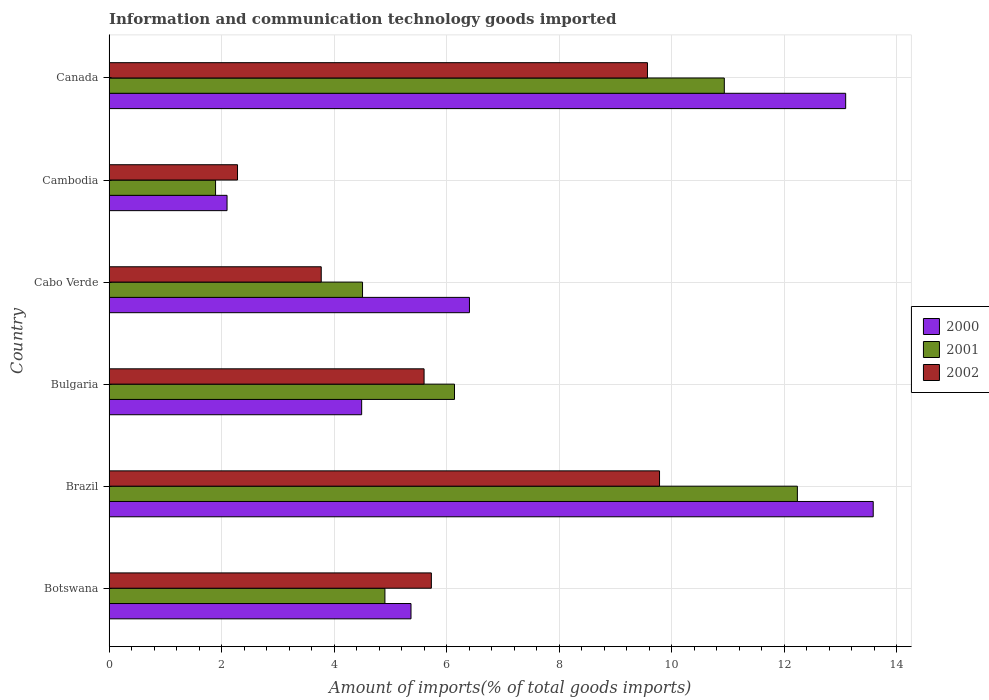How many different coloured bars are there?
Provide a succinct answer. 3. What is the label of the 1st group of bars from the top?
Provide a short and direct response. Canada. In how many cases, is the number of bars for a given country not equal to the number of legend labels?
Offer a very short reply. 0. What is the amount of goods imported in 2002 in Brazil?
Provide a succinct answer. 9.78. Across all countries, what is the maximum amount of goods imported in 2000?
Offer a terse response. 13.58. Across all countries, what is the minimum amount of goods imported in 2000?
Your response must be concise. 2.1. In which country was the amount of goods imported in 2002 maximum?
Your response must be concise. Brazil. In which country was the amount of goods imported in 2001 minimum?
Your answer should be very brief. Cambodia. What is the total amount of goods imported in 2001 in the graph?
Your answer should be very brief. 40.6. What is the difference between the amount of goods imported in 2002 in Brazil and that in Cambodia?
Keep it short and to the point. 7.5. What is the difference between the amount of goods imported in 2002 in Canada and the amount of goods imported in 2001 in Cambodia?
Offer a terse response. 7.67. What is the average amount of goods imported in 2001 per country?
Give a very brief answer. 6.77. What is the difference between the amount of goods imported in 2002 and amount of goods imported in 2001 in Canada?
Ensure brevity in your answer.  -1.37. What is the ratio of the amount of goods imported in 2000 in Brazil to that in Canada?
Keep it short and to the point. 1.04. What is the difference between the highest and the second highest amount of goods imported in 2001?
Make the answer very short. 1.3. What is the difference between the highest and the lowest amount of goods imported in 2002?
Provide a succinct answer. 7.5. In how many countries, is the amount of goods imported in 2001 greater than the average amount of goods imported in 2001 taken over all countries?
Your response must be concise. 2. Is the sum of the amount of goods imported in 2000 in Bulgaria and Canada greater than the maximum amount of goods imported in 2001 across all countries?
Offer a terse response. Yes. What does the 2nd bar from the top in Botswana represents?
Provide a succinct answer. 2001. What is the difference between two consecutive major ticks on the X-axis?
Give a very brief answer. 2. Does the graph contain grids?
Your answer should be very brief. Yes. What is the title of the graph?
Offer a very short reply. Information and communication technology goods imported. What is the label or title of the X-axis?
Provide a short and direct response. Amount of imports(% of total goods imports). What is the label or title of the Y-axis?
Give a very brief answer. Country. What is the Amount of imports(% of total goods imports) of 2000 in Botswana?
Provide a short and direct response. 5.37. What is the Amount of imports(% of total goods imports) of 2001 in Botswana?
Ensure brevity in your answer.  4.9. What is the Amount of imports(% of total goods imports) of 2002 in Botswana?
Your answer should be compact. 5.73. What is the Amount of imports(% of total goods imports) in 2000 in Brazil?
Offer a very short reply. 13.58. What is the Amount of imports(% of total goods imports) of 2001 in Brazil?
Give a very brief answer. 12.23. What is the Amount of imports(% of total goods imports) of 2002 in Brazil?
Keep it short and to the point. 9.78. What is the Amount of imports(% of total goods imports) in 2000 in Bulgaria?
Provide a short and direct response. 4.49. What is the Amount of imports(% of total goods imports) of 2001 in Bulgaria?
Give a very brief answer. 6.14. What is the Amount of imports(% of total goods imports) of 2002 in Bulgaria?
Offer a terse response. 5.6. What is the Amount of imports(% of total goods imports) of 2000 in Cabo Verde?
Your answer should be compact. 6.4. What is the Amount of imports(% of total goods imports) in 2001 in Cabo Verde?
Provide a succinct answer. 4.5. What is the Amount of imports(% of total goods imports) of 2002 in Cabo Verde?
Your answer should be compact. 3.77. What is the Amount of imports(% of total goods imports) of 2000 in Cambodia?
Keep it short and to the point. 2.1. What is the Amount of imports(% of total goods imports) in 2001 in Cambodia?
Provide a succinct answer. 1.89. What is the Amount of imports(% of total goods imports) in 2002 in Cambodia?
Provide a short and direct response. 2.28. What is the Amount of imports(% of total goods imports) in 2000 in Canada?
Provide a short and direct response. 13.09. What is the Amount of imports(% of total goods imports) of 2001 in Canada?
Provide a succinct answer. 10.93. What is the Amount of imports(% of total goods imports) of 2002 in Canada?
Your response must be concise. 9.57. Across all countries, what is the maximum Amount of imports(% of total goods imports) of 2000?
Keep it short and to the point. 13.58. Across all countries, what is the maximum Amount of imports(% of total goods imports) in 2001?
Keep it short and to the point. 12.23. Across all countries, what is the maximum Amount of imports(% of total goods imports) of 2002?
Your response must be concise. 9.78. Across all countries, what is the minimum Amount of imports(% of total goods imports) of 2000?
Ensure brevity in your answer.  2.1. Across all countries, what is the minimum Amount of imports(% of total goods imports) of 2001?
Your answer should be compact. 1.89. Across all countries, what is the minimum Amount of imports(% of total goods imports) in 2002?
Your answer should be compact. 2.28. What is the total Amount of imports(% of total goods imports) in 2000 in the graph?
Offer a very short reply. 45.02. What is the total Amount of imports(% of total goods imports) of 2001 in the graph?
Give a very brief answer. 40.6. What is the total Amount of imports(% of total goods imports) of 2002 in the graph?
Keep it short and to the point. 36.72. What is the difference between the Amount of imports(% of total goods imports) of 2000 in Botswana and that in Brazil?
Ensure brevity in your answer.  -8.21. What is the difference between the Amount of imports(% of total goods imports) of 2001 in Botswana and that in Brazil?
Ensure brevity in your answer.  -7.33. What is the difference between the Amount of imports(% of total goods imports) in 2002 in Botswana and that in Brazil?
Your answer should be very brief. -4.05. What is the difference between the Amount of imports(% of total goods imports) of 2000 in Botswana and that in Bulgaria?
Give a very brief answer. 0.88. What is the difference between the Amount of imports(% of total goods imports) of 2001 in Botswana and that in Bulgaria?
Ensure brevity in your answer.  -1.24. What is the difference between the Amount of imports(% of total goods imports) in 2002 in Botswana and that in Bulgaria?
Your answer should be compact. 0.13. What is the difference between the Amount of imports(% of total goods imports) in 2000 in Botswana and that in Cabo Verde?
Your answer should be compact. -1.04. What is the difference between the Amount of imports(% of total goods imports) in 2001 in Botswana and that in Cabo Verde?
Give a very brief answer. 0.4. What is the difference between the Amount of imports(% of total goods imports) of 2002 in Botswana and that in Cabo Verde?
Your answer should be very brief. 1.96. What is the difference between the Amount of imports(% of total goods imports) of 2000 in Botswana and that in Cambodia?
Offer a very short reply. 3.27. What is the difference between the Amount of imports(% of total goods imports) in 2001 in Botswana and that in Cambodia?
Offer a terse response. 3.01. What is the difference between the Amount of imports(% of total goods imports) of 2002 in Botswana and that in Cambodia?
Offer a terse response. 3.44. What is the difference between the Amount of imports(% of total goods imports) in 2000 in Botswana and that in Canada?
Provide a short and direct response. -7.72. What is the difference between the Amount of imports(% of total goods imports) of 2001 in Botswana and that in Canada?
Keep it short and to the point. -6.03. What is the difference between the Amount of imports(% of total goods imports) in 2002 in Botswana and that in Canada?
Provide a short and direct response. -3.84. What is the difference between the Amount of imports(% of total goods imports) of 2000 in Brazil and that in Bulgaria?
Ensure brevity in your answer.  9.09. What is the difference between the Amount of imports(% of total goods imports) of 2001 in Brazil and that in Bulgaria?
Your answer should be very brief. 6.09. What is the difference between the Amount of imports(% of total goods imports) of 2002 in Brazil and that in Bulgaria?
Ensure brevity in your answer.  4.18. What is the difference between the Amount of imports(% of total goods imports) of 2000 in Brazil and that in Cabo Verde?
Your response must be concise. 7.17. What is the difference between the Amount of imports(% of total goods imports) of 2001 in Brazil and that in Cabo Verde?
Your answer should be compact. 7.73. What is the difference between the Amount of imports(% of total goods imports) in 2002 in Brazil and that in Cabo Verde?
Your response must be concise. 6.01. What is the difference between the Amount of imports(% of total goods imports) of 2000 in Brazil and that in Cambodia?
Provide a short and direct response. 11.48. What is the difference between the Amount of imports(% of total goods imports) in 2001 in Brazil and that in Cambodia?
Offer a very short reply. 10.34. What is the difference between the Amount of imports(% of total goods imports) of 2002 in Brazil and that in Cambodia?
Ensure brevity in your answer.  7.5. What is the difference between the Amount of imports(% of total goods imports) in 2000 in Brazil and that in Canada?
Make the answer very short. 0.49. What is the difference between the Amount of imports(% of total goods imports) in 2001 in Brazil and that in Canada?
Keep it short and to the point. 1.3. What is the difference between the Amount of imports(% of total goods imports) in 2002 in Brazil and that in Canada?
Your answer should be very brief. 0.21. What is the difference between the Amount of imports(% of total goods imports) of 2000 in Bulgaria and that in Cabo Verde?
Give a very brief answer. -1.92. What is the difference between the Amount of imports(% of total goods imports) in 2001 in Bulgaria and that in Cabo Verde?
Provide a short and direct response. 1.63. What is the difference between the Amount of imports(% of total goods imports) of 2002 in Bulgaria and that in Cabo Verde?
Provide a succinct answer. 1.83. What is the difference between the Amount of imports(% of total goods imports) in 2000 in Bulgaria and that in Cambodia?
Offer a very short reply. 2.39. What is the difference between the Amount of imports(% of total goods imports) in 2001 in Bulgaria and that in Cambodia?
Ensure brevity in your answer.  4.25. What is the difference between the Amount of imports(% of total goods imports) in 2002 in Bulgaria and that in Cambodia?
Your answer should be compact. 3.31. What is the difference between the Amount of imports(% of total goods imports) of 2000 in Bulgaria and that in Canada?
Offer a terse response. -8.6. What is the difference between the Amount of imports(% of total goods imports) of 2001 in Bulgaria and that in Canada?
Your answer should be very brief. -4.79. What is the difference between the Amount of imports(% of total goods imports) in 2002 in Bulgaria and that in Canada?
Give a very brief answer. -3.97. What is the difference between the Amount of imports(% of total goods imports) in 2000 in Cabo Verde and that in Cambodia?
Offer a terse response. 4.31. What is the difference between the Amount of imports(% of total goods imports) of 2001 in Cabo Verde and that in Cambodia?
Keep it short and to the point. 2.61. What is the difference between the Amount of imports(% of total goods imports) of 2002 in Cabo Verde and that in Cambodia?
Provide a short and direct response. 1.49. What is the difference between the Amount of imports(% of total goods imports) in 2000 in Cabo Verde and that in Canada?
Your answer should be compact. -6.68. What is the difference between the Amount of imports(% of total goods imports) of 2001 in Cabo Verde and that in Canada?
Give a very brief answer. -6.43. What is the difference between the Amount of imports(% of total goods imports) of 2002 in Cabo Verde and that in Canada?
Give a very brief answer. -5.8. What is the difference between the Amount of imports(% of total goods imports) in 2000 in Cambodia and that in Canada?
Offer a very short reply. -10.99. What is the difference between the Amount of imports(% of total goods imports) of 2001 in Cambodia and that in Canada?
Your answer should be compact. -9.04. What is the difference between the Amount of imports(% of total goods imports) of 2002 in Cambodia and that in Canada?
Your response must be concise. -7.28. What is the difference between the Amount of imports(% of total goods imports) of 2000 in Botswana and the Amount of imports(% of total goods imports) of 2001 in Brazil?
Provide a succinct answer. -6.87. What is the difference between the Amount of imports(% of total goods imports) in 2000 in Botswana and the Amount of imports(% of total goods imports) in 2002 in Brazil?
Your response must be concise. -4.42. What is the difference between the Amount of imports(% of total goods imports) in 2001 in Botswana and the Amount of imports(% of total goods imports) in 2002 in Brazil?
Ensure brevity in your answer.  -4.88. What is the difference between the Amount of imports(% of total goods imports) in 2000 in Botswana and the Amount of imports(% of total goods imports) in 2001 in Bulgaria?
Your answer should be very brief. -0.77. What is the difference between the Amount of imports(% of total goods imports) of 2000 in Botswana and the Amount of imports(% of total goods imports) of 2002 in Bulgaria?
Your response must be concise. -0.23. What is the difference between the Amount of imports(% of total goods imports) of 2001 in Botswana and the Amount of imports(% of total goods imports) of 2002 in Bulgaria?
Make the answer very short. -0.7. What is the difference between the Amount of imports(% of total goods imports) of 2000 in Botswana and the Amount of imports(% of total goods imports) of 2001 in Cabo Verde?
Make the answer very short. 0.86. What is the difference between the Amount of imports(% of total goods imports) of 2000 in Botswana and the Amount of imports(% of total goods imports) of 2002 in Cabo Verde?
Provide a succinct answer. 1.6. What is the difference between the Amount of imports(% of total goods imports) of 2001 in Botswana and the Amount of imports(% of total goods imports) of 2002 in Cabo Verde?
Keep it short and to the point. 1.13. What is the difference between the Amount of imports(% of total goods imports) in 2000 in Botswana and the Amount of imports(% of total goods imports) in 2001 in Cambodia?
Your response must be concise. 3.47. What is the difference between the Amount of imports(% of total goods imports) in 2000 in Botswana and the Amount of imports(% of total goods imports) in 2002 in Cambodia?
Keep it short and to the point. 3.08. What is the difference between the Amount of imports(% of total goods imports) of 2001 in Botswana and the Amount of imports(% of total goods imports) of 2002 in Cambodia?
Give a very brief answer. 2.62. What is the difference between the Amount of imports(% of total goods imports) of 2000 in Botswana and the Amount of imports(% of total goods imports) of 2001 in Canada?
Ensure brevity in your answer.  -5.57. What is the difference between the Amount of imports(% of total goods imports) of 2000 in Botswana and the Amount of imports(% of total goods imports) of 2002 in Canada?
Your answer should be very brief. -4.2. What is the difference between the Amount of imports(% of total goods imports) in 2001 in Botswana and the Amount of imports(% of total goods imports) in 2002 in Canada?
Make the answer very short. -4.67. What is the difference between the Amount of imports(% of total goods imports) in 2000 in Brazil and the Amount of imports(% of total goods imports) in 2001 in Bulgaria?
Your answer should be compact. 7.44. What is the difference between the Amount of imports(% of total goods imports) in 2000 in Brazil and the Amount of imports(% of total goods imports) in 2002 in Bulgaria?
Offer a very short reply. 7.98. What is the difference between the Amount of imports(% of total goods imports) in 2001 in Brazil and the Amount of imports(% of total goods imports) in 2002 in Bulgaria?
Provide a succinct answer. 6.63. What is the difference between the Amount of imports(% of total goods imports) in 2000 in Brazil and the Amount of imports(% of total goods imports) in 2001 in Cabo Verde?
Your response must be concise. 9.07. What is the difference between the Amount of imports(% of total goods imports) in 2000 in Brazil and the Amount of imports(% of total goods imports) in 2002 in Cabo Verde?
Give a very brief answer. 9.81. What is the difference between the Amount of imports(% of total goods imports) in 2001 in Brazil and the Amount of imports(% of total goods imports) in 2002 in Cabo Verde?
Your response must be concise. 8.46. What is the difference between the Amount of imports(% of total goods imports) of 2000 in Brazil and the Amount of imports(% of total goods imports) of 2001 in Cambodia?
Offer a terse response. 11.69. What is the difference between the Amount of imports(% of total goods imports) in 2000 in Brazil and the Amount of imports(% of total goods imports) in 2002 in Cambodia?
Your answer should be very brief. 11.3. What is the difference between the Amount of imports(% of total goods imports) of 2001 in Brazil and the Amount of imports(% of total goods imports) of 2002 in Cambodia?
Give a very brief answer. 9.95. What is the difference between the Amount of imports(% of total goods imports) of 2000 in Brazil and the Amount of imports(% of total goods imports) of 2001 in Canada?
Make the answer very short. 2.65. What is the difference between the Amount of imports(% of total goods imports) in 2000 in Brazil and the Amount of imports(% of total goods imports) in 2002 in Canada?
Ensure brevity in your answer.  4.01. What is the difference between the Amount of imports(% of total goods imports) in 2001 in Brazil and the Amount of imports(% of total goods imports) in 2002 in Canada?
Keep it short and to the point. 2.66. What is the difference between the Amount of imports(% of total goods imports) of 2000 in Bulgaria and the Amount of imports(% of total goods imports) of 2001 in Cabo Verde?
Provide a succinct answer. -0.02. What is the difference between the Amount of imports(% of total goods imports) of 2000 in Bulgaria and the Amount of imports(% of total goods imports) of 2002 in Cabo Verde?
Offer a very short reply. 0.72. What is the difference between the Amount of imports(% of total goods imports) in 2001 in Bulgaria and the Amount of imports(% of total goods imports) in 2002 in Cabo Verde?
Your response must be concise. 2.37. What is the difference between the Amount of imports(% of total goods imports) in 2000 in Bulgaria and the Amount of imports(% of total goods imports) in 2001 in Cambodia?
Make the answer very short. 2.6. What is the difference between the Amount of imports(% of total goods imports) of 2000 in Bulgaria and the Amount of imports(% of total goods imports) of 2002 in Cambodia?
Make the answer very short. 2.21. What is the difference between the Amount of imports(% of total goods imports) in 2001 in Bulgaria and the Amount of imports(% of total goods imports) in 2002 in Cambodia?
Give a very brief answer. 3.86. What is the difference between the Amount of imports(% of total goods imports) in 2000 in Bulgaria and the Amount of imports(% of total goods imports) in 2001 in Canada?
Provide a short and direct response. -6.44. What is the difference between the Amount of imports(% of total goods imports) in 2000 in Bulgaria and the Amount of imports(% of total goods imports) in 2002 in Canada?
Provide a succinct answer. -5.08. What is the difference between the Amount of imports(% of total goods imports) in 2001 in Bulgaria and the Amount of imports(% of total goods imports) in 2002 in Canada?
Offer a very short reply. -3.43. What is the difference between the Amount of imports(% of total goods imports) of 2000 in Cabo Verde and the Amount of imports(% of total goods imports) of 2001 in Cambodia?
Your answer should be compact. 4.51. What is the difference between the Amount of imports(% of total goods imports) in 2000 in Cabo Verde and the Amount of imports(% of total goods imports) in 2002 in Cambodia?
Offer a very short reply. 4.12. What is the difference between the Amount of imports(% of total goods imports) of 2001 in Cabo Verde and the Amount of imports(% of total goods imports) of 2002 in Cambodia?
Keep it short and to the point. 2.22. What is the difference between the Amount of imports(% of total goods imports) in 2000 in Cabo Verde and the Amount of imports(% of total goods imports) in 2001 in Canada?
Your answer should be compact. -4.53. What is the difference between the Amount of imports(% of total goods imports) in 2000 in Cabo Verde and the Amount of imports(% of total goods imports) in 2002 in Canada?
Your answer should be compact. -3.16. What is the difference between the Amount of imports(% of total goods imports) in 2001 in Cabo Verde and the Amount of imports(% of total goods imports) in 2002 in Canada?
Ensure brevity in your answer.  -5.06. What is the difference between the Amount of imports(% of total goods imports) in 2000 in Cambodia and the Amount of imports(% of total goods imports) in 2001 in Canada?
Offer a very short reply. -8.84. What is the difference between the Amount of imports(% of total goods imports) of 2000 in Cambodia and the Amount of imports(% of total goods imports) of 2002 in Canada?
Your answer should be compact. -7.47. What is the difference between the Amount of imports(% of total goods imports) in 2001 in Cambodia and the Amount of imports(% of total goods imports) in 2002 in Canada?
Your answer should be very brief. -7.67. What is the average Amount of imports(% of total goods imports) in 2000 per country?
Your answer should be compact. 7.5. What is the average Amount of imports(% of total goods imports) of 2001 per country?
Ensure brevity in your answer.  6.77. What is the average Amount of imports(% of total goods imports) in 2002 per country?
Provide a short and direct response. 6.12. What is the difference between the Amount of imports(% of total goods imports) in 2000 and Amount of imports(% of total goods imports) in 2001 in Botswana?
Your answer should be very brief. 0.46. What is the difference between the Amount of imports(% of total goods imports) in 2000 and Amount of imports(% of total goods imports) in 2002 in Botswana?
Your response must be concise. -0.36. What is the difference between the Amount of imports(% of total goods imports) in 2001 and Amount of imports(% of total goods imports) in 2002 in Botswana?
Provide a short and direct response. -0.83. What is the difference between the Amount of imports(% of total goods imports) in 2000 and Amount of imports(% of total goods imports) in 2001 in Brazil?
Ensure brevity in your answer.  1.35. What is the difference between the Amount of imports(% of total goods imports) of 2000 and Amount of imports(% of total goods imports) of 2002 in Brazil?
Your answer should be compact. 3.8. What is the difference between the Amount of imports(% of total goods imports) of 2001 and Amount of imports(% of total goods imports) of 2002 in Brazil?
Your response must be concise. 2.45. What is the difference between the Amount of imports(% of total goods imports) of 2000 and Amount of imports(% of total goods imports) of 2001 in Bulgaria?
Provide a short and direct response. -1.65. What is the difference between the Amount of imports(% of total goods imports) in 2000 and Amount of imports(% of total goods imports) in 2002 in Bulgaria?
Your answer should be compact. -1.11. What is the difference between the Amount of imports(% of total goods imports) of 2001 and Amount of imports(% of total goods imports) of 2002 in Bulgaria?
Keep it short and to the point. 0.54. What is the difference between the Amount of imports(% of total goods imports) in 2000 and Amount of imports(% of total goods imports) in 2001 in Cabo Verde?
Make the answer very short. 1.9. What is the difference between the Amount of imports(% of total goods imports) of 2000 and Amount of imports(% of total goods imports) of 2002 in Cabo Verde?
Provide a short and direct response. 2.63. What is the difference between the Amount of imports(% of total goods imports) in 2001 and Amount of imports(% of total goods imports) in 2002 in Cabo Verde?
Provide a succinct answer. 0.73. What is the difference between the Amount of imports(% of total goods imports) of 2000 and Amount of imports(% of total goods imports) of 2001 in Cambodia?
Offer a very short reply. 0.2. What is the difference between the Amount of imports(% of total goods imports) in 2000 and Amount of imports(% of total goods imports) in 2002 in Cambodia?
Give a very brief answer. -0.19. What is the difference between the Amount of imports(% of total goods imports) of 2001 and Amount of imports(% of total goods imports) of 2002 in Cambodia?
Keep it short and to the point. -0.39. What is the difference between the Amount of imports(% of total goods imports) of 2000 and Amount of imports(% of total goods imports) of 2001 in Canada?
Keep it short and to the point. 2.16. What is the difference between the Amount of imports(% of total goods imports) in 2000 and Amount of imports(% of total goods imports) in 2002 in Canada?
Give a very brief answer. 3.52. What is the difference between the Amount of imports(% of total goods imports) of 2001 and Amount of imports(% of total goods imports) of 2002 in Canada?
Give a very brief answer. 1.37. What is the ratio of the Amount of imports(% of total goods imports) of 2000 in Botswana to that in Brazil?
Make the answer very short. 0.4. What is the ratio of the Amount of imports(% of total goods imports) in 2001 in Botswana to that in Brazil?
Ensure brevity in your answer.  0.4. What is the ratio of the Amount of imports(% of total goods imports) in 2002 in Botswana to that in Brazil?
Provide a short and direct response. 0.59. What is the ratio of the Amount of imports(% of total goods imports) in 2000 in Botswana to that in Bulgaria?
Your answer should be very brief. 1.2. What is the ratio of the Amount of imports(% of total goods imports) of 2001 in Botswana to that in Bulgaria?
Make the answer very short. 0.8. What is the ratio of the Amount of imports(% of total goods imports) of 2002 in Botswana to that in Bulgaria?
Provide a succinct answer. 1.02. What is the ratio of the Amount of imports(% of total goods imports) of 2000 in Botswana to that in Cabo Verde?
Your response must be concise. 0.84. What is the ratio of the Amount of imports(% of total goods imports) in 2001 in Botswana to that in Cabo Verde?
Offer a very short reply. 1.09. What is the ratio of the Amount of imports(% of total goods imports) of 2002 in Botswana to that in Cabo Verde?
Offer a terse response. 1.52. What is the ratio of the Amount of imports(% of total goods imports) in 2000 in Botswana to that in Cambodia?
Give a very brief answer. 2.56. What is the ratio of the Amount of imports(% of total goods imports) in 2001 in Botswana to that in Cambodia?
Offer a very short reply. 2.59. What is the ratio of the Amount of imports(% of total goods imports) of 2002 in Botswana to that in Cambodia?
Ensure brevity in your answer.  2.51. What is the ratio of the Amount of imports(% of total goods imports) of 2000 in Botswana to that in Canada?
Offer a very short reply. 0.41. What is the ratio of the Amount of imports(% of total goods imports) in 2001 in Botswana to that in Canada?
Your answer should be very brief. 0.45. What is the ratio of the Amount of imports(% of total goods imports) of 2002 in Botswana to that in Canada?
Make the answer very short. 0.6. What is the ratio of the Amount of imports(% of total goods imports) in 2000 in Brazil to that in Bulgaria?
Your response must be concise. 3.03. What is the ratio of the Amount of imports(% of total goods imports) in 2001 in Brazil to that in Bulgaria?
Offer a very short reply. 1.99. What is the ratio of the Amount of imports(% of total goods imports) of 2002 in Brazil to that in Bulgaria?
Your answer should be very brief. 1.75. What is the ratio of the Amount of imports(% of total goods imports) in 2000 in Brazil to that in Cabo Verde?
Provide a short and direct response. 2.12. What is the ratio of the Amount of imports(% of total goods imports) in 2001 in Brazil to that in Cabo Verde?
Provide a succinct answer. 2.72. What is the ratio of the Amount of imports(% of total goods imports) of 2002 in Brazil to that in Cabo Verde?
Offer a very short reply. 2.59. What is the ratio of the Amount of imports(% of total goods imports) of 2000 in Brazil to that in Cambodia?
Provide a short and direct response. 6.48. What is the ratio of the Amount of imports(% of total goods imports) of 2001 in Brazil to that in Cambodia?
Your answer should be very brief. 6.46. What is the ratio of the Amount of imports(% of total goods imports) of 2002 in Brazil to that in Cambodia?
Your answer should be compact. 4.29. What is the ratio of the Amount of imports(% of total goods imports) in 2000 in Brazil to that in Canada?
Keep it short and to the point. 1.04. What is the ratio of the Amount of imports(% of total goods imports) in 2001 in Brazil to that in Canada?
Give a very brief answer. 1.12. What is the ratio of the Amount of imports(% of total goods imports) in 2002 in Brazil to that in Canada?
Offer a very short reply. 1.02. What is the ratio of the Amount of imports(% of total goods imports) in 2000 in Bulgaria to that in Cabo Verde?
Provide a succinct answer. 0.7. What is the ratio of the Amount of imports(% of total goods imports) of 2001 in Bulgaria to that in Cabo Verde?
Ensure brevity in your answer.  1.36. What is the ratio of the Amount of imports(% of total goods imports) of 2002 in Bulgaria to that in Cabo Verde?
Offer a terse response. 1.48. What is the ratio of the Amount of imports(% of total goods imports) of 2000 in Bulgaria to that in Cambodia?
Your response must be concise. 2.14. What is the ratio of the Amount of imports(% of total goods imports) of 2001 in Bulgaria to that in Cambodia?
Your response must be concise. 3.24. What is the ratio of the Amount of imports(% of total goods imports) of 2002 in Bulgaria to that in Cambodia?
Provide a short and direct response. 2.45. What is the ratio of the Amount of imports(% of total goods imports) in 2000 in Bulgaria to that in Canada?
Keep it short and to the point. 0.34. What is the ratio of the Amount of imports(% of total goods imports) in 2001 in Bulgaria to that in Canada?
Your answer should be compact. 0.56. What is the ratio of the Amount of imports(% of total goods imports) of 2002 in Bulgaria to that in Canada?
Ensure brevity in your answer.  0.59. What is the ratio of the Amount of imports(% of total goods imports) in 2000 in Cabo Verde to that in Cambodia?
Your answer should be compact. 3.05. What is the ratio of the Amount of imports(% of total goods imports) in 2001 in Cabo Verde to that in Cambodia?
Your answer should be very brief. 2.38. What is the ratio of the Amount of imports(% of total goods imports) in 2002 in Cabo Verde to that in Cambodia?
Provide a short and direct response. 1.65. What is the ratio of the Amount of imports(% of total goods imports) of 2000 in Cabo Verde to that in Canada?
Your answer should be compact. 0.49. What is the ratio of the Amount of imports(% of total goods imports) of 2001 in Cabo Verde to that in Canada?
Keep it short and to the point. 0.41. What is the ratio of the Amount of imports(% of total goods imports) in 2002 in Cabo Verde to that in Canada?
Provide a short and direct response. 0.39. What is the ratio of the Amount of imports(% of total goods imports) in 2000 in Cambodia to that in Canada?
Make the answer very short. 0.16. What is the ratio of the Amount of imports(% of total goods imports) in 2001 in Cambodia to that in Canada?
Give a very brief answer. 0.17. What is the ratio of the Amount of imports(% of total goods imports) in 2002 in Cambodia to that in Canada?
Give a very brief answer. 0.24. What is the difference between the highest and the second highest Amount of imports(% of total goods imports) of 2000?
Offer a terse response. 0.49. What is the difference between the highest and the second highest Amount of imports(% of total goods imports) in 2001?
Give a very brief answer. 1.3. What is the difference between the highest and the second highest Amount of imports(% of total goods imports) of 2002?
Your answer should be compact. 0.21. What is the difference between the highest and the lowest Amount of imports(% of total goods imports) in 2000?
Your answer should be very brief. 11.48. What is the difference between the highest and the lowest Amount of imports(% of total goods imports) of 2001?
Give a very brief answer. 10.34. What is the difference between the highest and the lowest Amount of imports(% of total goods imports) in 2002?
Your answer should be compact. 7.5. 